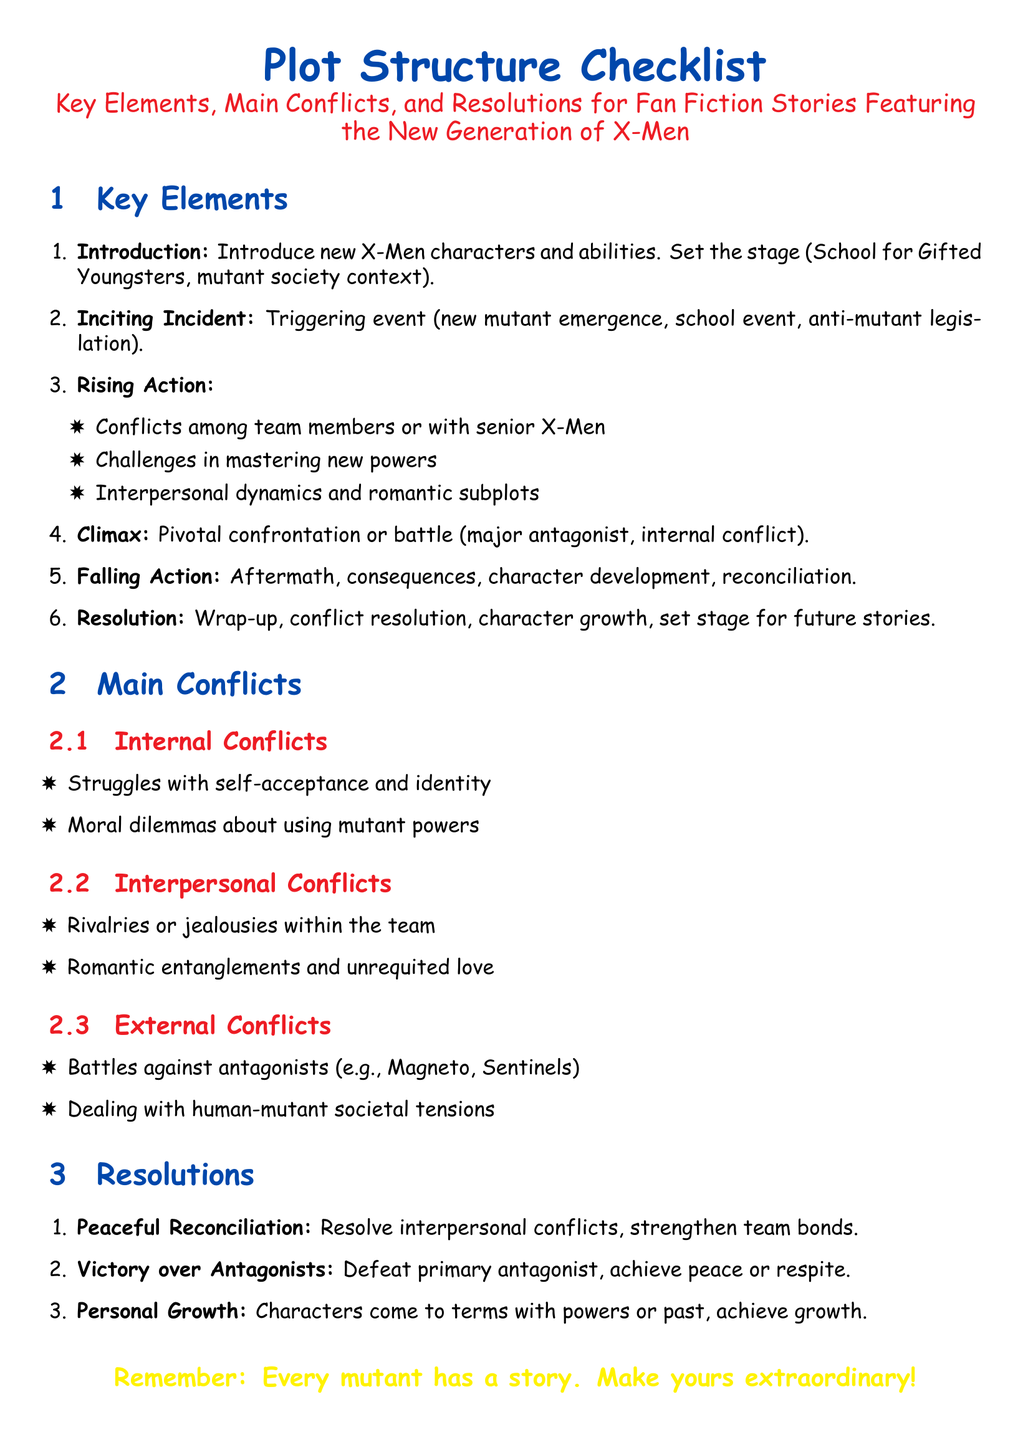What is the title of the document? The title is presented in the document's header section, which is "Plot Structure Checklist: Key Elements, Main Conflicts, and Resolutions for Fan Fiction Stories Featuring the New Generation of X-Men."
Answer: Plot Structure Checklist: Key Elements, Main Conflicts, and Resolutions for Fan Fiction Stories Featuring the New Generation of X-Men What color is used for section titles? The section titles are formatted with a specific color, which is defined in the document as mutant blue.
Answer: mutant blue How many main conflict categories are listed? The document outlines different categories under the main conflicts section, which are Internal Conflicts, Interpersonal Conflicts, and External Conflicts, totaling three.
Answer: 3 What is the climax of the story referred to in the document? The document specifies the climax as a pivotal confrontation or battle involving the major antagonist or internal conflict within the story.
Answer: Pivotal confrontation or battle What is one example of an external conflict listed? The document provides specific examples of external conflicts, one of which is battles against antagonists like Magneto or Sentinels.
Answer: Battles against antagonists What resolution type involves personal growth? The document categorizes personal growth under its resolutions section, stating characters come to terms with their powers or past to achieve growth.
Answer: Personal Growth How many key elements are outlined in the checklist? The checklist elaborates on six key elements that structure the plot of the fan fiction stories.
Answer: 6 What color is used for the concluding statement in the document? The concluding statement includes a specific color formatting defined in the document, which is mutant yellow.
Answer: mutant yellow 